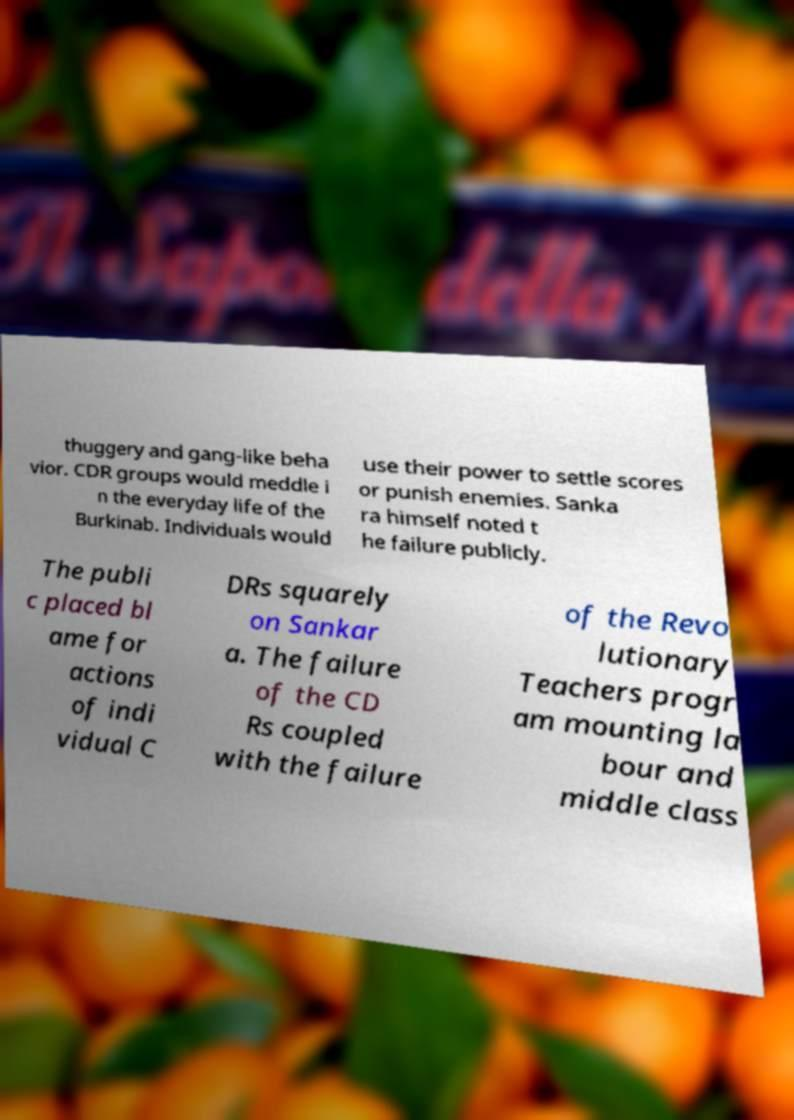Could you assist in decoding the text presented in this image and type it out clearly? thuggery and gang-like beha vior. CDR groups would meddle i n the everyday life of the Burkinab. Individuals would use their power to settle scores or punish enemies. Sanka ra himself noted t he failure publicly. The publi c placed bl ame for actions of indi vidual C DRs squarely on Sankar a. The failure of the CD Rs coupled with the failure of the Revo lutionary Teachers progr am mounting la bour and middle class 